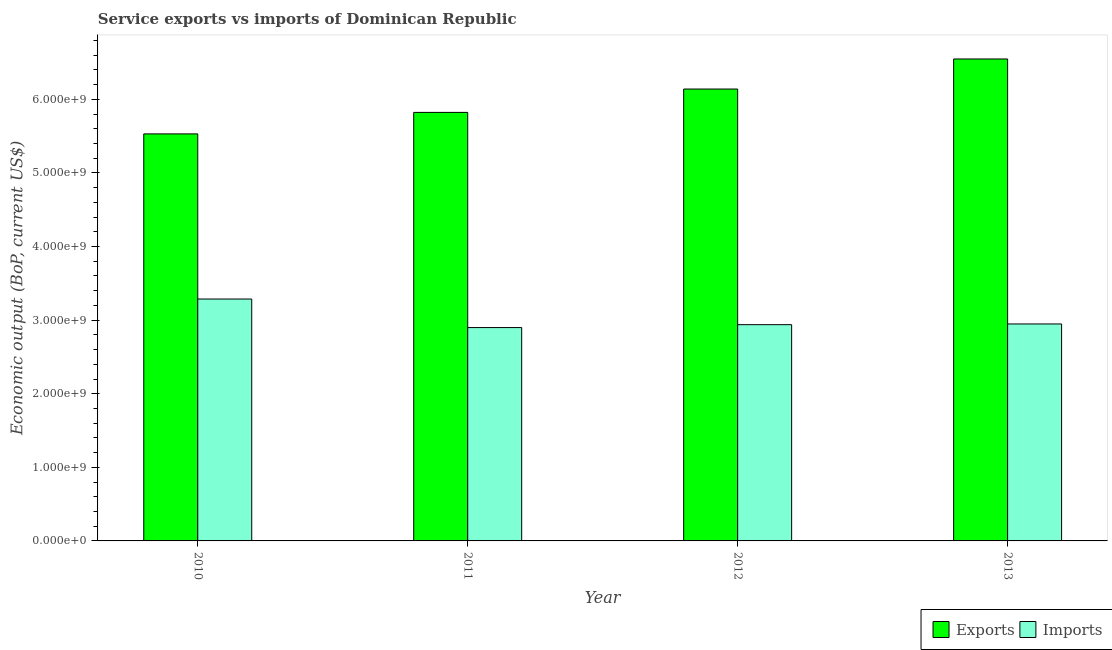Are the number of bars per tick equal to the number of legend labels?
Give a very brief answer. Yes. How many bars are there on the 1st tick from the right?
Your response must be concise. 2. In how many cases, is the number of bars for a given year not equal to the number of legend labels?
Your answer should be very brief. 0. What is the amount of service exports in 2012?
Offer a terse response. 6.14e+09. Across all years, what is the maximum amount of service exports?
Give a very brief answer. 6.55e+09. Across all years, what is the minimum amount of service imports?
Give a very brief answer. 2.90e+09. In which year was the amount of service exports maximum?
Your answer should be compact. 2013. In which year was the amount of service exports minimum?
Give a very brief answer. 2010. What is the total amount of service exports in the graph?
Keep it short and to the point. 2.40e+1. What is the difference between the amount of service imports in 2011 and that in 2013?
Keep it short and to the point. -4.90e+07. What is the difference between the amount of service exports in 2013 and the amount of service imports in 2010?
Make the answer very short. 1.02e+09. What is the average amount of service imports per year?
Give a very brief answer. 3.02e+09. In how many years, is the amount of service exports greater than 800000000 US$?
Keep it short and to the point. 4. What is the ratio of the amount of service exports in 2010 to that in 2011?
Your response must be concise. 0.95. Is the amount of service imports in 2011 less than that in 2013?
Your answer should be compact. Yes. What is the difference between the highest and the second highest amount of service imports?
Ensure brevity in your answer.  3.39e+08. What is the difference between the highest and the lowest amount of service imports?
Give a very brief answer. 3.88e+08. What does the 1st bar from the left in 2010 represents?
Offer a very short reply. Exports. What does the 2nd bar from the right in 2012 represents?
Your response must be concise. Exports. Are all the bars in the graph horizontal?
Ensure brevity in your answer.  No. What is the difference between two consecutive major ticks on the Y-axis?
Provide a succinct answer. 1.00e+09. Are the values on the major ticks of Y-axis written in scientific E-notation?
Your response must be concise. Yes. Where does the legend appear in the graph?
Your answer should be very brief. Bottom right. How are the legend labels stacked?
Ensure brevity in your answer.  Horizontal. What is the title of the graph?
Provide a short and direct response. Service exports vs imports of Dominican Republic. What is the label or title of the X-axis?
Make the answer very short. Year. What is the label or title of the Y-axis?
Offer a very short reply. Economic output (BoP, current US$). What is the Economic output (BoP, current US$) of Exports in 2010?
Ensure brevity in your answer.  5.53e+09. What is the Economic output (BoP, current US$) in Imports in 2010?
Keep it short and to the point. 3.29e+09. What is the Economic output (BoP, current US$) in Exports in 2011?
Keep it short and to the point. 5.82e+09. What is the Economic output (BoP, current US$) of Imports in 2011?
Give a very brief answer. 2.90e+09. What is the Economic output (BoP, current US$) in Exports in 2012?
Your answer should be compact. 6.14e+09. What is the Economic output (BoP, current US$) of Imports in 2012?
Ensure brevity in your answer.  2.94e+09. What is the Economic output (BoP, current US$) in Exports in 2013?
Ensure brevity in your answer.  6.55e+09. What is the Economic output (BoP, current US$) of Imports in 2013?
Provide a succinct answer. 2.95e+09. Across all years, what is the maximum Economic output (BoP, current US$) in Exports?
Provide a short and direct response. 6.55e+09. Across all years, what is the maximum Economic output (BoP, current US$) of Imports?
Your answer should be very brief. 3.29e+09. Across all years, what is the minimum Economic output (BoP, current US$) of Exports?
Your answer should be compact. 5.53e+09. Across all years, what is the minimum Economic output (BoP, current US$) in Imports?
Your answer should be very brief. 2.90e+09. What is the total Economic output (BoP, current US$) in Exports in the graph?
Provide a succinct answer. 2.40e+1. What is the total Economic output (BoP, current US$) of Imports in the graph?
Provide a succinct answer. 1.21e+1. What is the difference between the Economic output (BoP, current US$) of Exports in 2010 and that in 2011?
Your answer should be very brief. -2.92e+08. What is the difference between the Economic output (BoP, current US$) in Imports in 2010 and that in 2011?
Ensure brevity in your answer.  3.88e+08. What is the difference between the Economic output (BoP, current US$) in Exports in 2010 and that in 2012?
Your response must be concise. -6.10e+08. What is the difference between the Economic output (BoP, current US$) of Imports in 2010 and that in 2012?
Provide a short and direct response. 3.48e+08. What is the difference between the Economic output (BoP, current US$) of Exports in 2010 and that in 2013?
Give a very brief answer. -1.02e+09. What is the difference between the Economic output (BoP, current US$) in Imports in 2010 and that in 2013?
Your answer should be compact. 3.39e+08. What is the difference between the Economic output (BoP, current US$) in Exports in 2011 and that in 2012?
Ensure brevity in your answer.  -3.17e+08. What is the difference between the Economic output (BoP, current US$) in Imports in 2011 and that in 2012?
Keep it short and to the point. -3.95e+07. What is the difference between the Economic output (BoP, current US$) in Exports in 2011 and that in 2013?
Your answer should be very brief. -7.26e+08. What is the difference between the Economic output (BoP, current US$) of Imports in 2011 and that in 2013?
Your answer should be very brief. -4.90e+07. What is the difference between the Economic output (BoP, current US$) of Exports in 2012 and that in 2013?
Your response must be concise. -4.09e+08. What is the difference between the Economic output (BoP, current US$) in Imports in 2012 and that in 2013?
Your response must be concise. -9.50e+06. What is the difference between the Economic output (BoP, current US$) in Exports in 2010 and the Economic output (BoP, current US$) in Imports in 2011?
Provide a short and direct response. 2.63e+09. What is the difference between the Economic output (BoP, current US$) in Exports in 2010 and the Economic output (BoP, current US$) in Imports in 2012?
Offer a very short reply. 2.59e+09. What is the difference between the Economic output (BoP, current US$) in Exports in 2010 and the Economic output (BoP, current US$) in Imports in 2013?
Provide a short and direct response. 2.58e+09. What is the difference between the Economic output (BoP, current US$) in Exports in 2011 and the Economic output (BoP, current US$) in Imports in 2012?
Provide a short and direct response. 2.88e+09. What is the difference between the Economic output (BoP, current US$) of Exports in 2011 and the Economic output (BoP, current US$) of Imports in 2013?
Provide a succinct answer. 2.87e+09. What is the difference between the Economic output (BoP, current US$) in Exports in 2012 and the Economic output (BoP, current US$) in Imports in 2013?
Offer a terse response. 3.19e+09. What is the average Economic output (BoP, current US$) of Exports per year?
Keep it short and to the point. 6.01e+09. What is the average Economic output (BoP, current US$) in Imports per year?
Provide a short and direct response. 3.02e+09. In the year 2010, what is the difference between the Economic output (BoP, current US$) in Exports and Economic output (BoP, current US$) in Imports?
Your response must be concise. 2.24e+09. In the year 2011, what is the difference between the Economic output (BoP, current US$) of Exports and Economic output (BoP, current US$) of Imports?
Provide a succinct answer. 2.92e+09. In the year 2012, what is the difference between the Economic output (BoP, current US$) in Exports and Economic output (BoP, current US$) in Imports?
Your answer should be very brief. 3.20e+09. In the year 2013, what is the difference between the Economic output (BoP, current US$) of Exports and Economic output (BoP, current US$) of Imports?
Your response must be concise. 3.60e+09. What is the ratio of the Economic output (BoP, current US$) of Exports in 2010 to that in 2011?
Offer a very short reply. 0.95. What is the ratio of the Economic output (BoP, current US$) of Imports in 2010 to that in 2011?
Your answer should be very brief. 1.13. What is the ratio of the Economic output (BoP, current US$) in Exports in 2010 to that in 2012?
Ensure brevity in your answer.  0.9. What is the ratio of the Economic output (BoP, current US$) in Imports in 2010 to that in 2012?
Provide a succinct answer. 1.12. What is the ratio of the Economic output (BoP, current US$) in Exports in 2010 to that in 2013?
Offer a terse response. 0.84. What is the ratio of the Economic output (BoP, current US$) in Imports in 2010 to that in 2013?
Your response must be concise. 1.11. What is the ratio of the Economic output (BoP, current US$) of Exports in 2011 to that in 2012?
Your response must be concise. 0.95. What is the ratio of the Economic output (BoP, current US$) in Imports in 2011 to that in 2012?
Offer a terse response. 0.99. What is the ratio of the Economic output (BoP, current US$) in Exports in 2011 to that in 2013?
Give a very brief answer. 0.89. What is the ratio of the Economic output (BoP, current US$) in Imports in 2011 to that in 2013?
Offer a terse response. 0.98. What is the ratio of the Economic output (BoP, current US$) in Exports in 2012 to that in 2013?
Your answer should be compact. 0.94. What is the ratio of the Economic output (BoP, current US$) in Imports in 2012 to that in 2013?
Offer a very short reply. 1. What is the difference between the highest and the second highest Economic output (BoP, current US$) in Exports?
Provide a succinct answer. 4.09e+08. What is the difference between the highest and the second highest Economic output (BoP, current US$) in Imports?
Give a very brief answer. 3.39e+08. What is the difference between the highest and the lowest Economic output (BoP, current US$) in Exports?
Make the answer very short. 1.02e+09. What is the difference between the highest and the lowest Economic output (BoP, current US$) in Imports?
Give a very brief answer. 3.88e+08. 